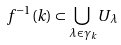<formula> <loc_0><loc_0><loc_500><loc_500>f ^ { - 1 } ( k ) \subset \bigcup _ { \lambda \in \gamma _ { k } } U _ { \lambda }</formula> 